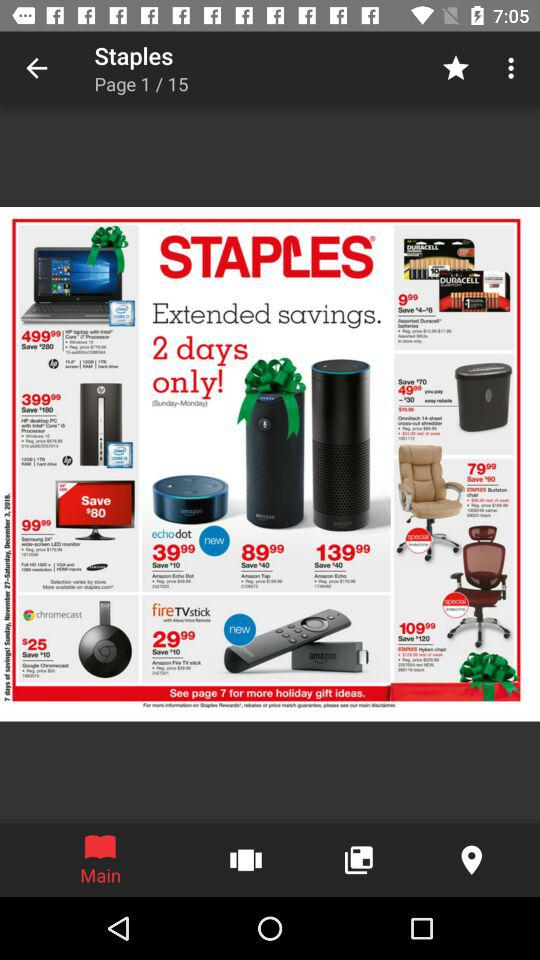What's the total number of pages? The total number of pages is 15. 